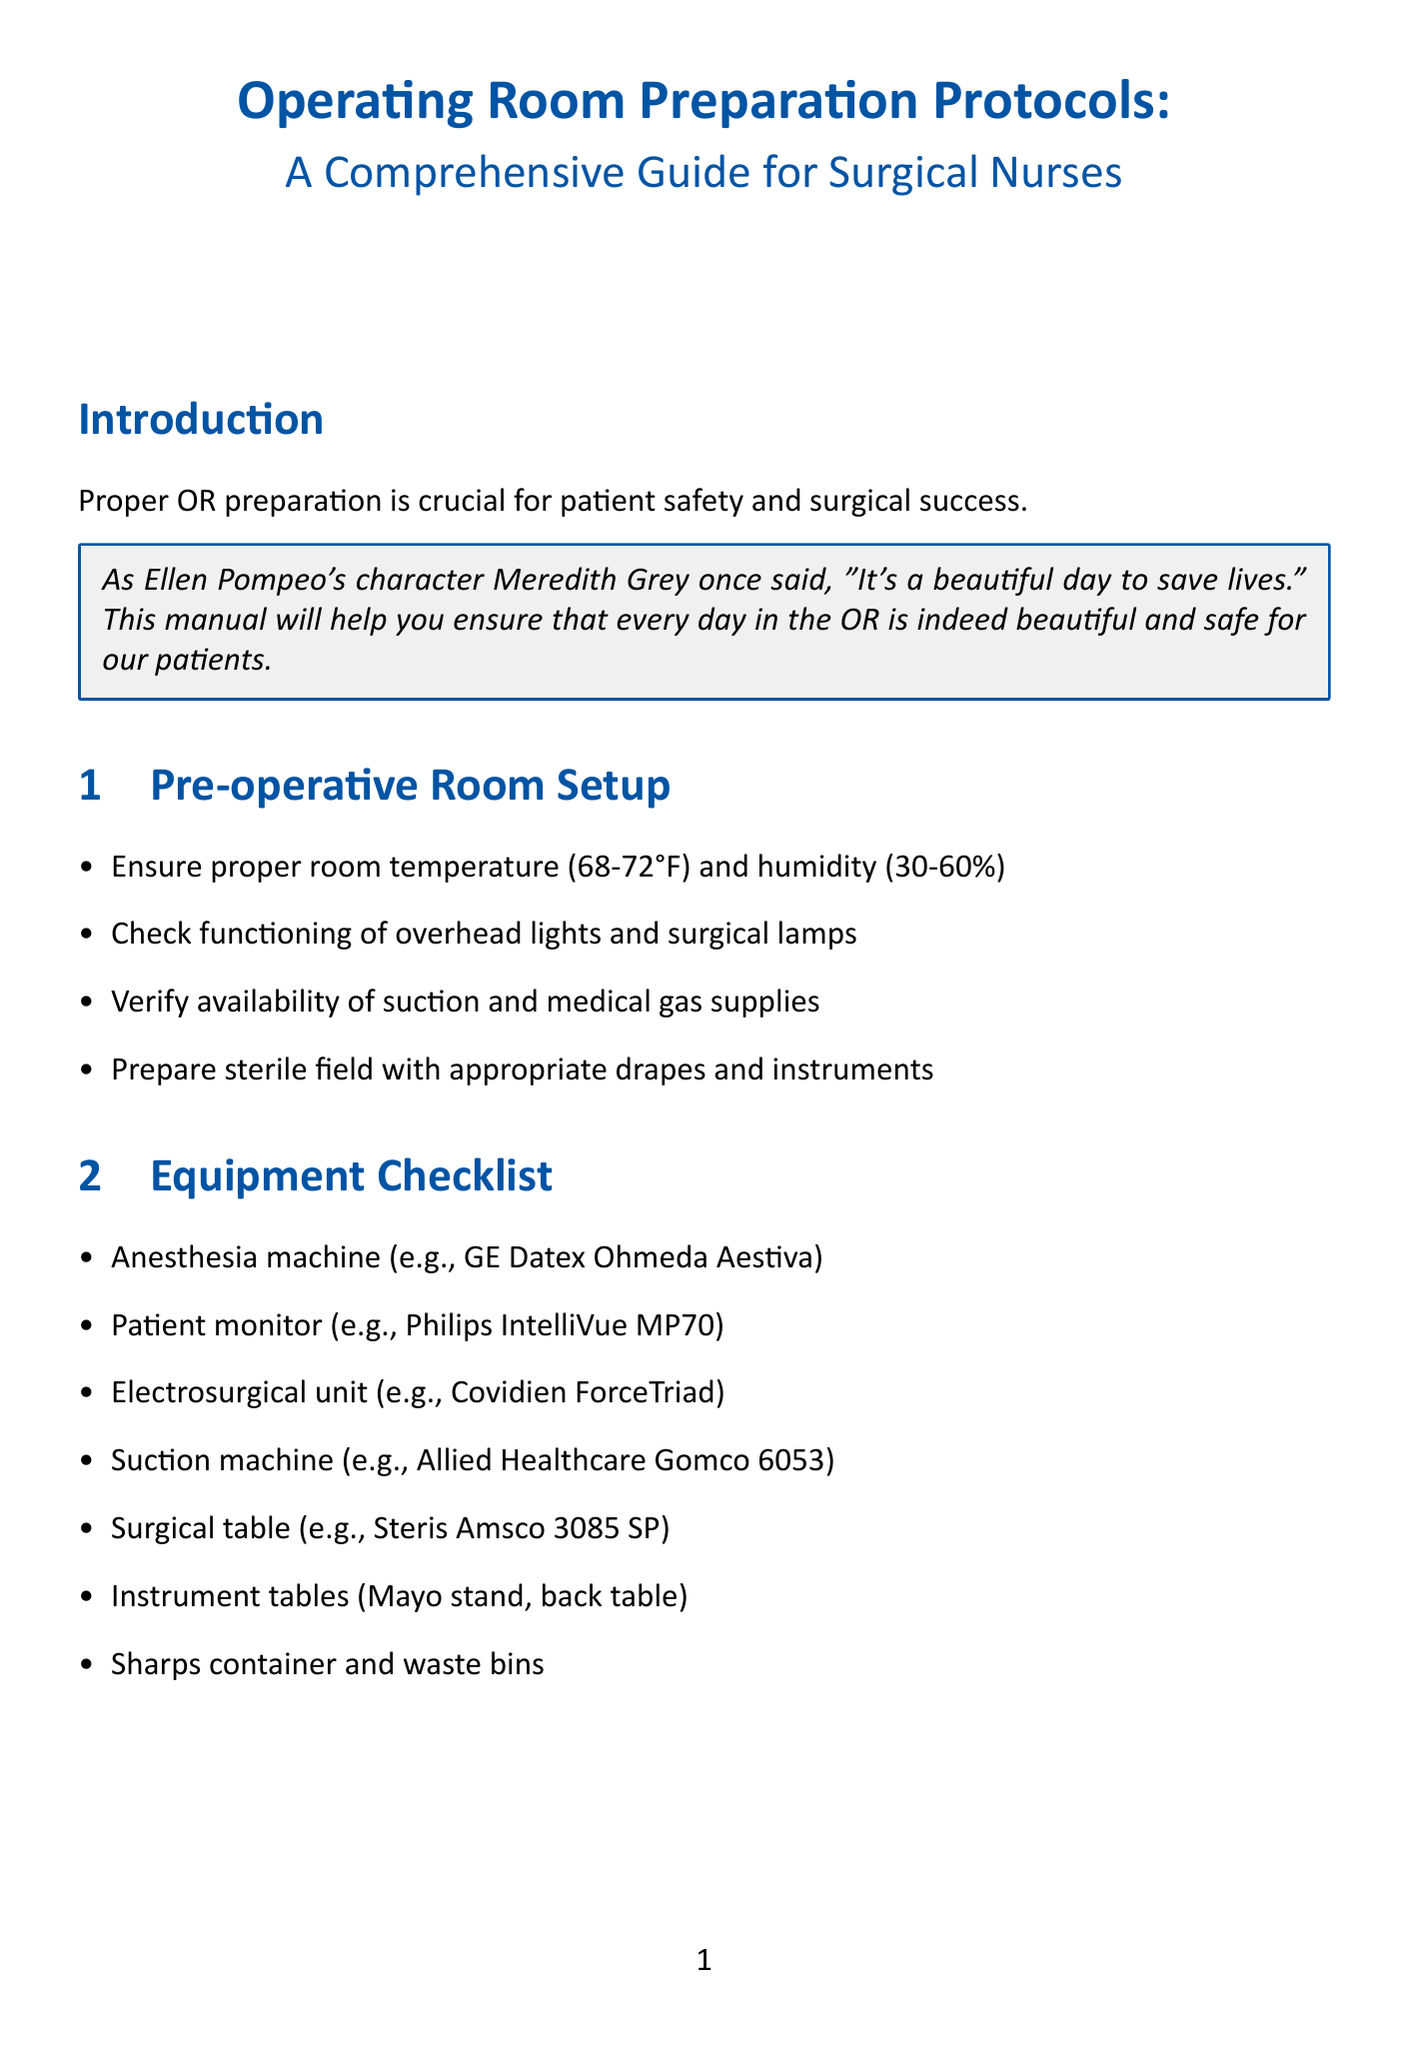What is the recommended room temperature for the OR? The manual specifies that the proper room temperature for the OR should be 68-72°F.
Answer: 68-72°F What is included in the equipment checklist? The equipment checklist contains essential surgical instruments and machines such as the anesthesia machine and patient monitor.
Answer: Anesthesia machine, patient monitor, electrosurgical unit, suction machine, surgical table, instrument tables, sharps container and waste bins What does the time-out procedure verify? The time-out procedure's purpose is to confirm the surgical site marking and the identity of the patient using two identifiers.
Answer: Surgical site marking and identity verification What must be maintained to ensure infection control? Infection control is achieved by adhering to specific protocols such as using chlorhexidine-alcohol for skin preparation and maintaining appropriate OR traffic.
Answer: Chlorhexidine-alcohol and OR traffic What is important for patient safety during surgery? Patient safety procedures emphasize verifying identity, surgical site marking, and accurate counting of sponges, sharps, and instruments.
Answer: Verify identity, confirm surgical site, accurate counting How should instruments be handled? The manual outlines that sterile instruments and supplies should be properly handled to maintain the sterile field throughout the procedure.
Answer: Proper handling of sterile instruments What should be checked on the crash cart? It is important to ensure that the defibrillator is charged as part of the emergency preparedness protocols regarding the crash cart.
Answer: Defibrillator charged What should be documented in the electronic health record? The documentation process must include recording all medications, implants, and specimens used during the surgical procedure.
Answer: All medications, implants, and specimens 